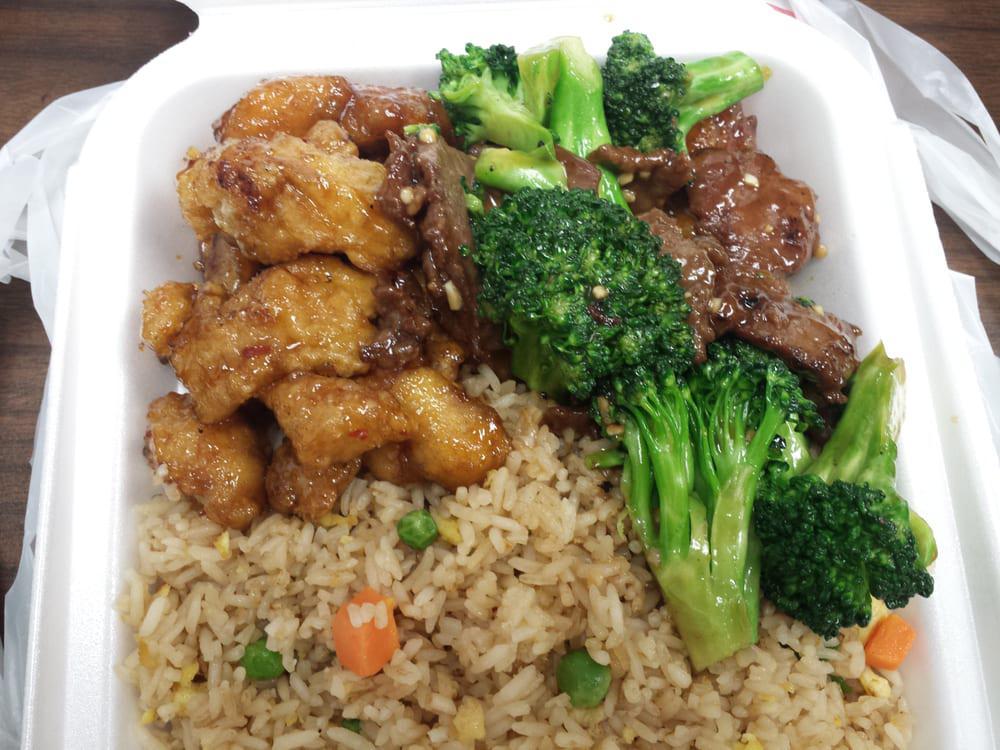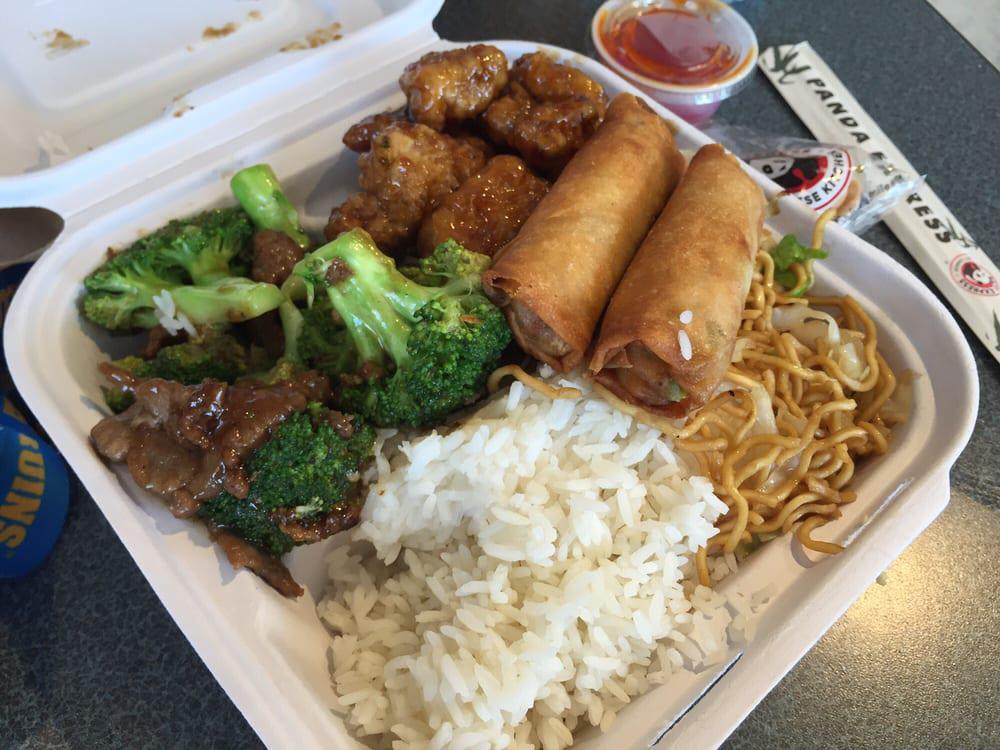The first image is the image on the left, the second image is the image on the right. Considering the images on both sides, is "One image shows a casserole with a wooden serving spoon, and the other image is at least one individual serving of casserole in a white bowl." valid? Answer yes or no. No. The first image is the image on the left, the second image is the image on the right. For the images displayed, is the sentence "A wooden spoon sits in a container of food." factually correct? Answer yes or no. No. 